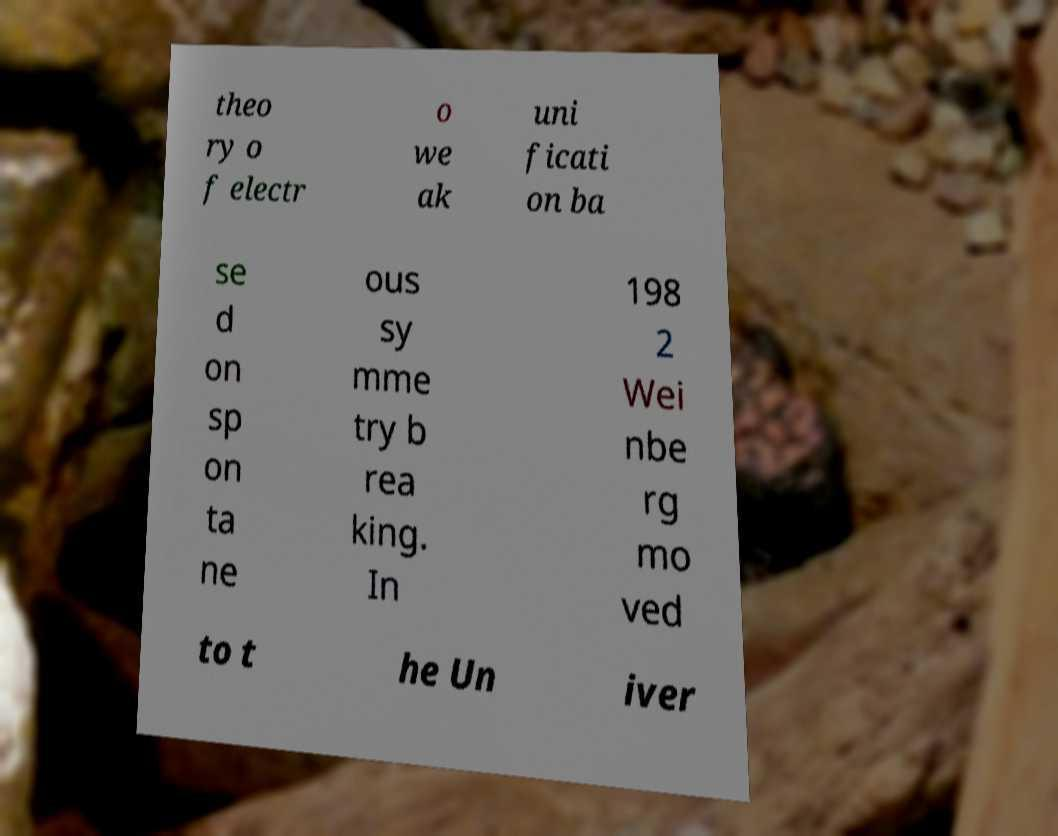What messages or text are displayed in this image? I need them in a readable, typed format. theo ry o f electr o we ak uni ficati on ba se d on sp on ta ne ous sy mme try b rea king. In 198 2 Wei nbe rg mo ved to t he Un iver 